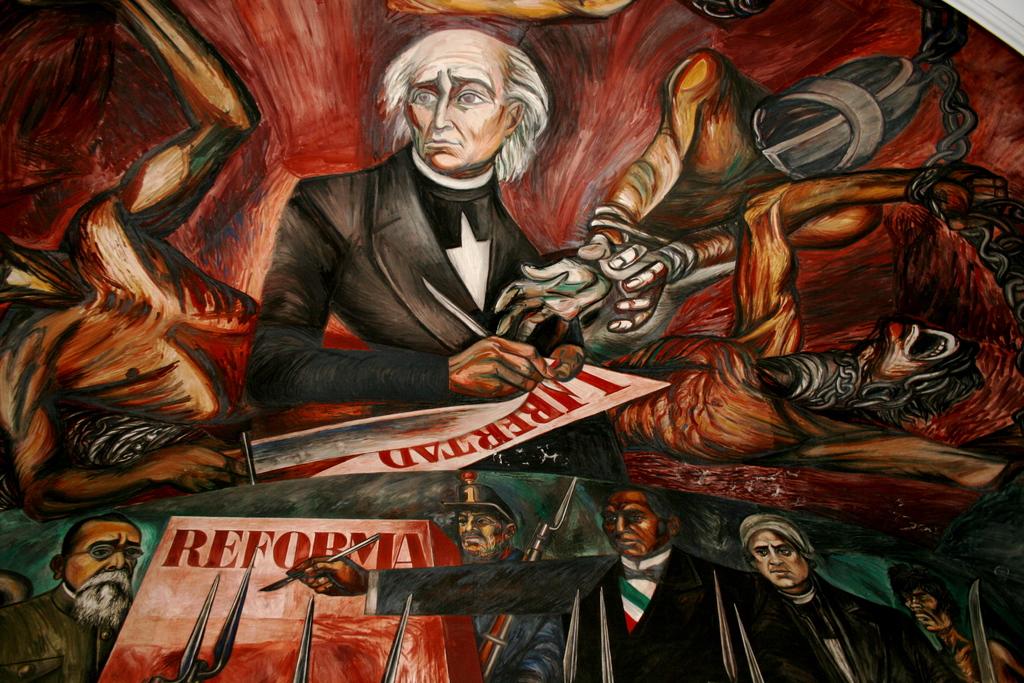What is this painting trying to portray?
Offer a very short reply. Reform. What color is the text in the painting?
Offer a very short reply. Red. 